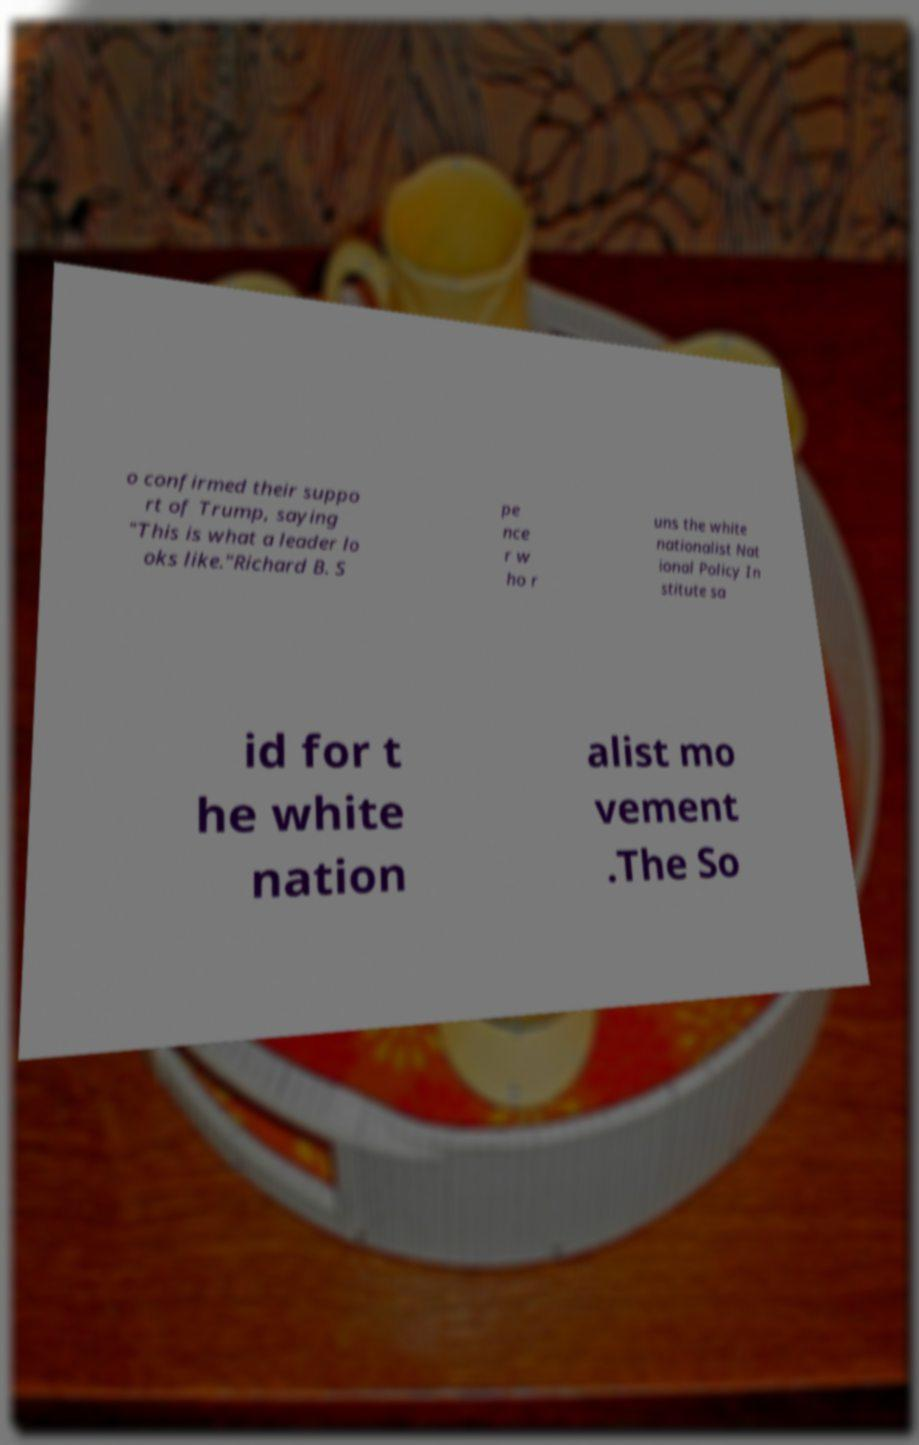Please identify and transcribe the text found in this image. o confirmed their suppo rt of Trump, saying "This is what a leader lo oks like."Richard B. S pe nce r w ho r uns the white nationalist Nat ional Policy In stitute sa id for t he white nation alist mo vement .The So 